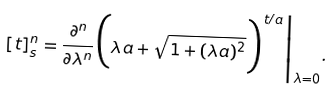<formula> <loc_0><loc_0><loc_500><loc_500>[ t ] _ { s } ^ { n } = \frac { \partial ^ { n } } { \partial \lambda ^ { n } } \Big ( \lambda a + \sqrt { 1 + ( \lambda a ) ^ { 2 } } \Big ) ^ { t / a } \Big | _ { \lambda = 0 } .</formula> 